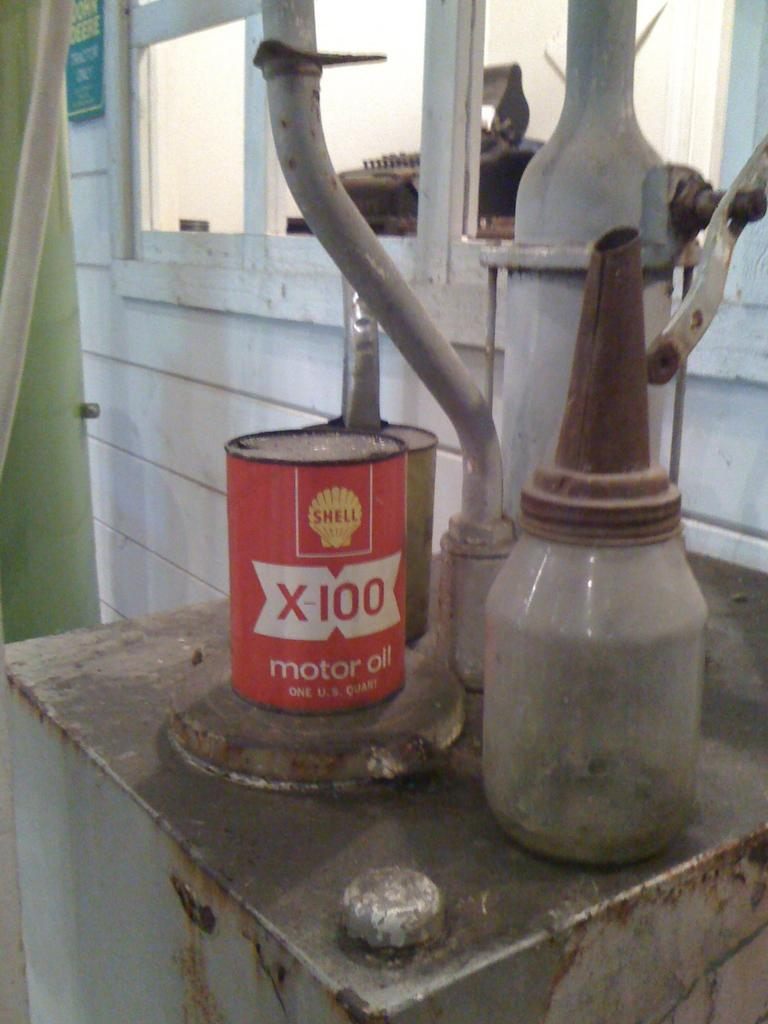What can be seen in the image? There are objects in the image. What is visible in the background of the image? There is a wall in the background of the image. Can you describe the wall in the image? There is a window on the wall. What is associated with the window in the image? There is a curtain associated with the window. How many crows are sitting on the trucks outside the window in the image? There are no trucks or crows present in the image. 